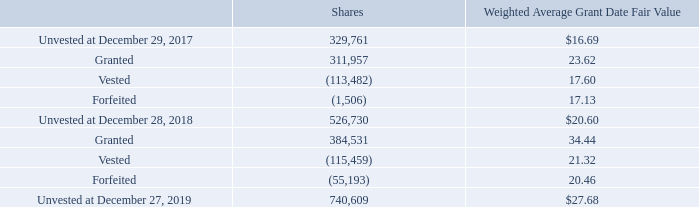Equity Incentive Plan
On May 17, 2019, the Company’s stockholders approved the 2019 Omnibus Equity Incentive Plan (the “2019 Plan”). Concurrently, the 2011 Omnibus Equity Incentive Plan (the “2011 Plan”) was terminated and any shares remaining available for new grants under the 2011 Plan share reserve were extinguished. The purpose of the 2019 Plan is to promote the interests of the Company and its stockholders by (i) attracting and retaining key officers, employees and directors of, and consultants to, the Company and its Subsidiaries and Affiliates; (ii) motivating such individuals by means of performance-related incentives to achieve long-range performance goals; (iii) enabling such individuals to participate in the long-term growth and financial success of the Company; (iv) encouraging ownership of stock in the Company by such individuals; and (v) linking their compensation to the long-term interests of the Company and its stockholders.
The 2019 Plan is administered by the Compensation and Human Capital Committee (the “Committee”) of the Board of Directors and allows for the issuance of stock options, stock appreciation rights (“SARs”), RSAs, restricted share units, performance awards, or other stock-based awards. Stock option exercise prices are fixed by the Committee but shall not be less than the fair market value of a common share on the date of the grant of the option, except in the case of substitute awards. Similarly, the grant price of an SAR may not be less than the fair market value of a common share on the date of the grant. The Committee will determine the expiration date of each stock option and SAR, but in no case shall the stock option or SAR be exercisable after the expiration of 10 years from the date of the grant. The 2019 Plan provides for 2,600,000 shares available for grant. As of December 27, 2019, there were 2,222,088 shares available for grant.
Stock compensation expense was $4,399, $4,094 and $3,018 for the fiscal years ended December 27, 2019, December 28, 2018 and December 29, 2017, respectively. The related tax benefit for stock-based compensation was $883, $864 and $1,283 for the fiscal years ended December 27, 2019, December 28, 2018 and December 29, 2017, respectively.
The following table reflects the activity of RSAs during the fiscal years ended December 27, 2019 and December 28, 2018:
The fair value of RSAs vested during the fiscal years ended December 27, 2019, December 28, 2018 and December 29, 2017, was $3,742, $2,936 and $1,703, respectively.
These awards are a mix of time-, market- and performance-based grants awarded to key employees and non-employee directors which vest over a range of periods of up to five-years. The market- and performance-based RSAs cliff vest, if at all, after the conclusion of a three-year performance period and vesting is subject to the award recipient’s continued service to the Company as of the vesting date. The number of performance-based RSAs that ultimately vest is based on the Company’s attainment of certain profitability and return on invested capital targets.
During fiscal 2019, the Company awarded market-based RSAs that vest based on the Company’s attainment of an average closing trade price of the Company’s common stock of $39.86 per share, based on an average of 20 consecutive trading days. The grant date fair value of these market-based performance awards was determined using a Monte Carlo simulation in order to simulate a range of possible future stock prices. Key assumptions used included a risk-free interest rate of 2.2% and expected volatility of 44.6%.
What is the number of shares that are Unvested at December 29, 2017? 329,761. What is the Stock compensation expense for the fiscal years ended December 27, 2019, December 28, 2018 and December 29, 2017, respectively? $4,399, $4,094, $3,018. When did the Company's stockholders approve the 2019 Omnibus Equity Incentive Plan? May 17, 2019. What is the average Stock compensation expense for the fiscal years ended December 27, 2019, December 28, 2018 and December 29, 2017? (4,399+ 4,094+ 3,018)/3
Answer: 3837. What is the change in the number of unvested shares between December 29, 2017 and December 28, 2018? 526,730-329,761
Answer: 196969. What is the average fair value of RSAs vested during the fiscal years ended December 27, 2019, December 28, 2018 and December 29, 2017? (3,742+ 2,936+ 1,703)/3
Answer: 2793.67. 